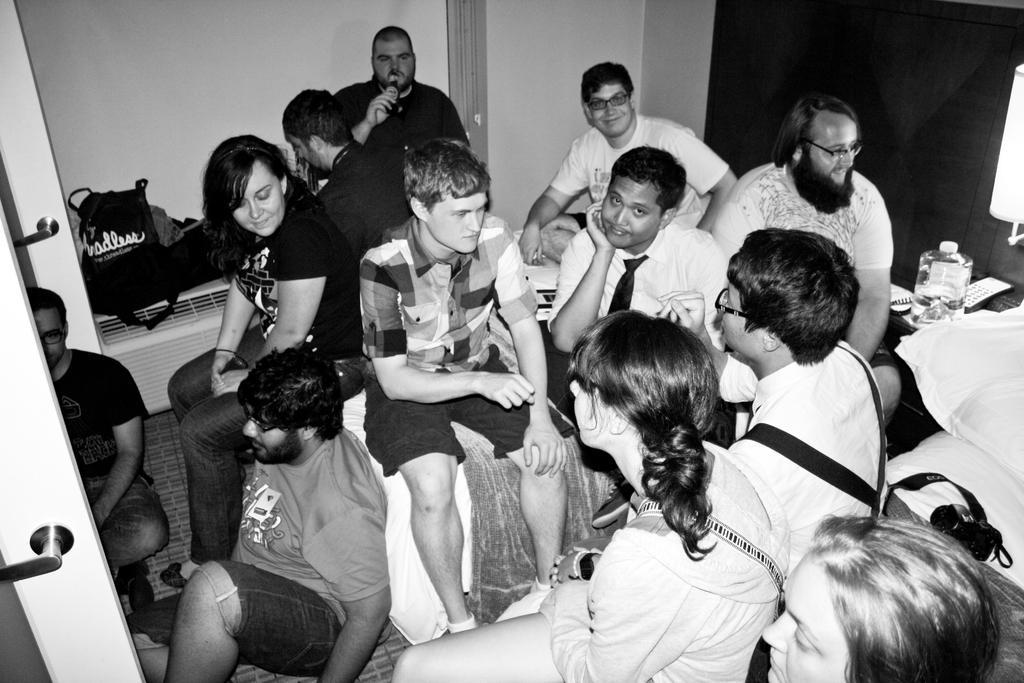Please provide a concise description of this image. In the foreground of this black and white image, there are people sitting on the beds and few are sitting on the floor. We can also see a camera on a bed, container on a table, a man holding a bottle, wall and few bags. 